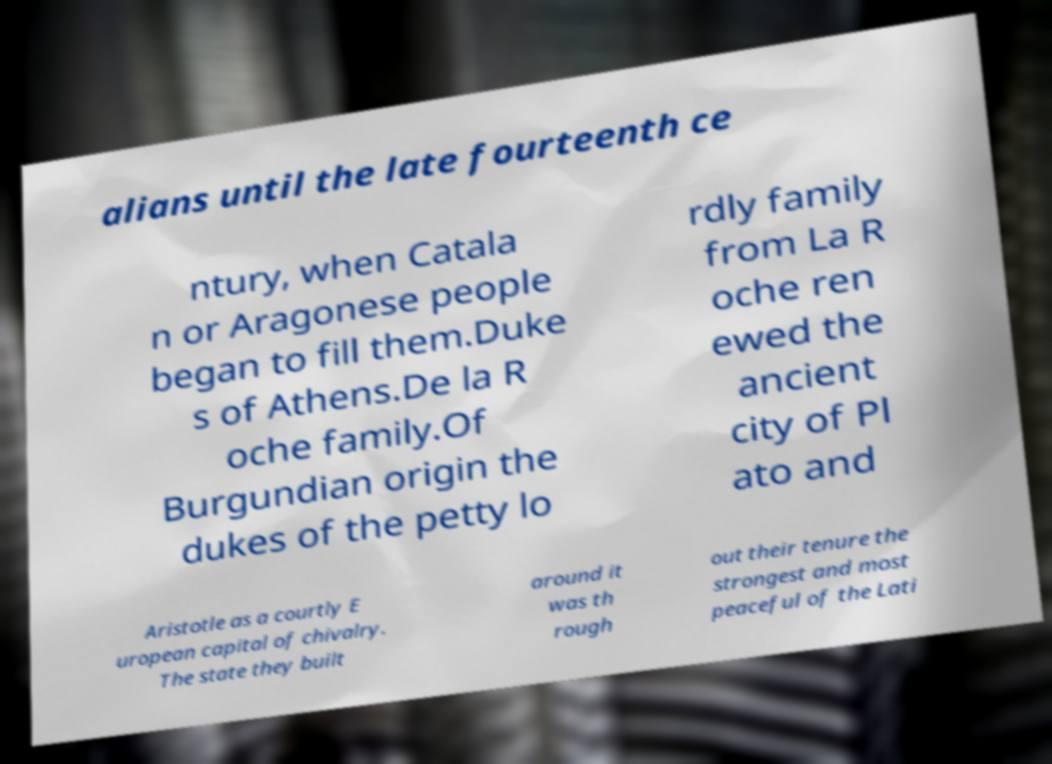For documentation purposes, I need the text within this image transcribed. Could you provide that? alians until the late fourteenth ce ntury, when Catala n or Aragonese people began to fill them.Duke s of Athens.De la R oche family.Of Burgundian origin the dukes of the petty lo rdly family from La R oche ren ewed the ancient city of Pl ato and Aristotle as a courtly E uropean capital of chivalry. The state they built around it was th rough out their tenure the strongest and most peaceful of the Lati 